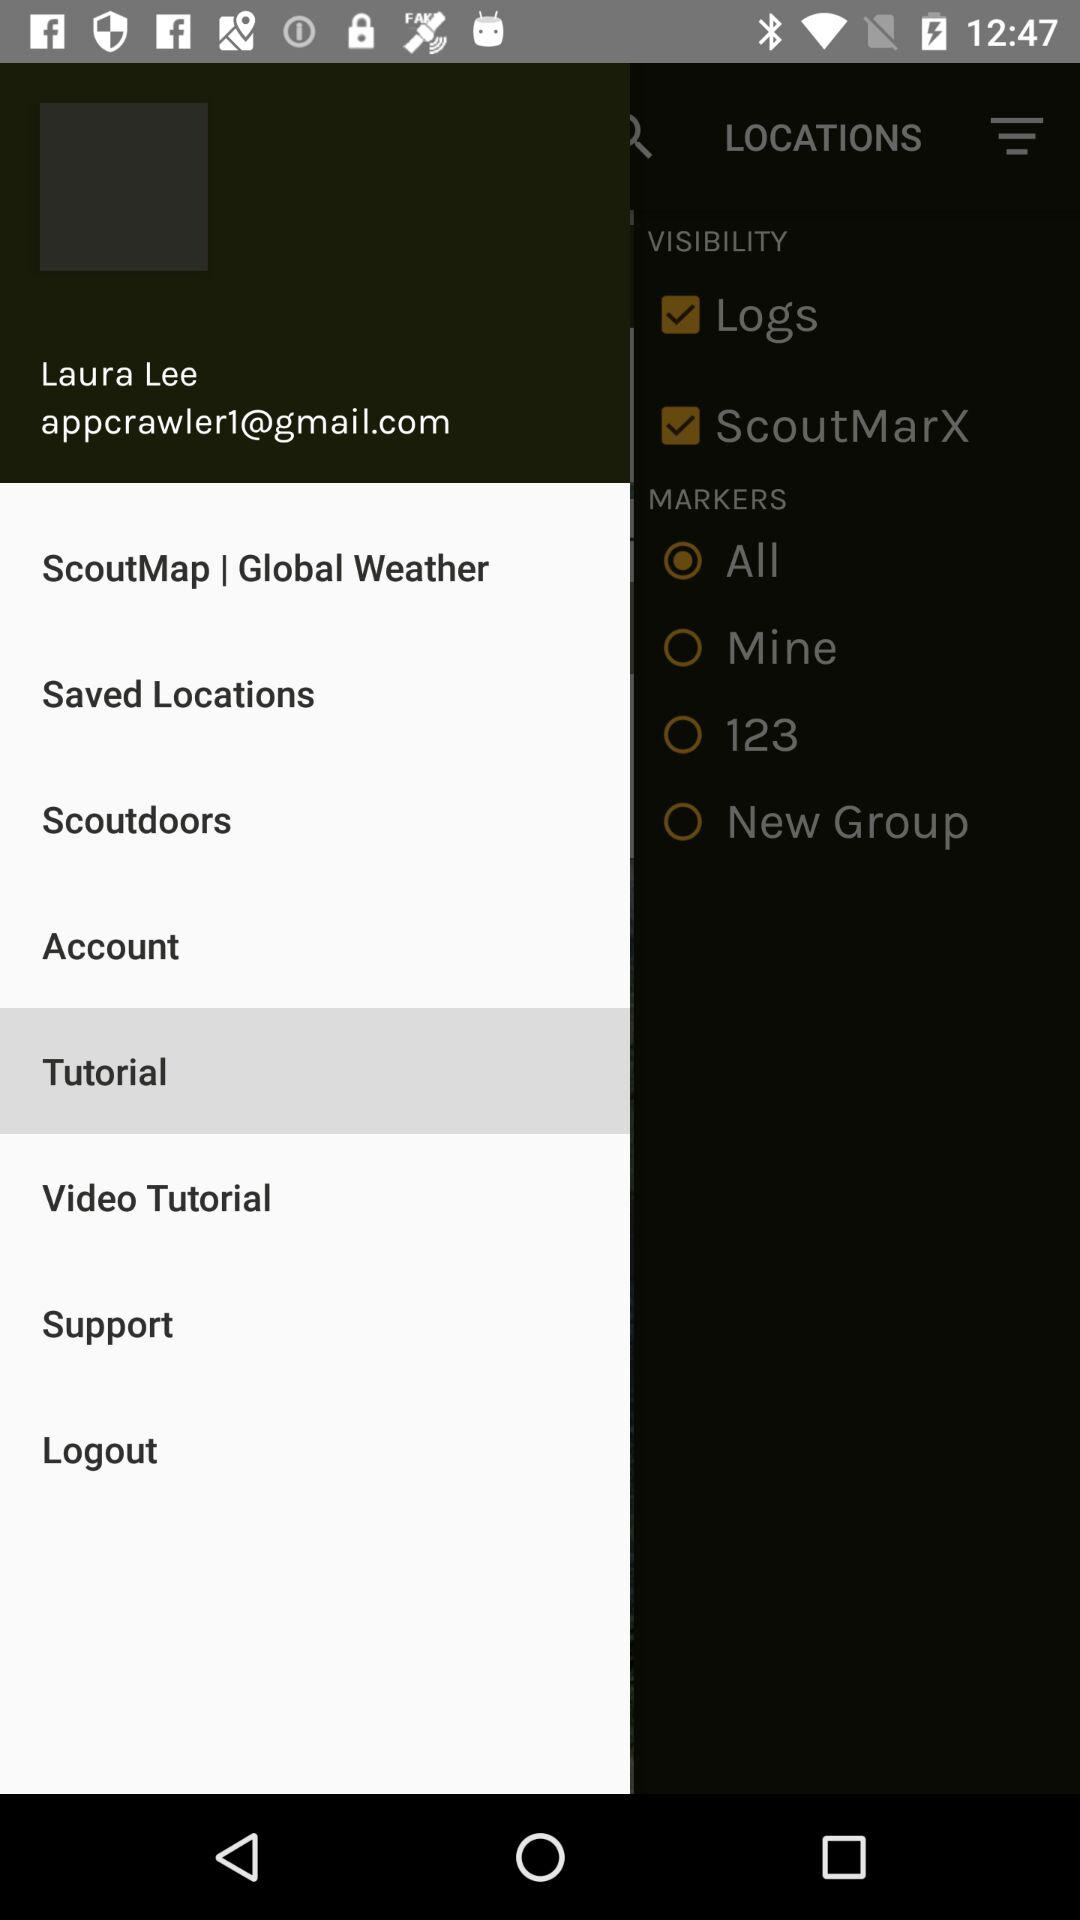What's the Google mail address? The Google mail address is "appcrawler1@gmail.com". 